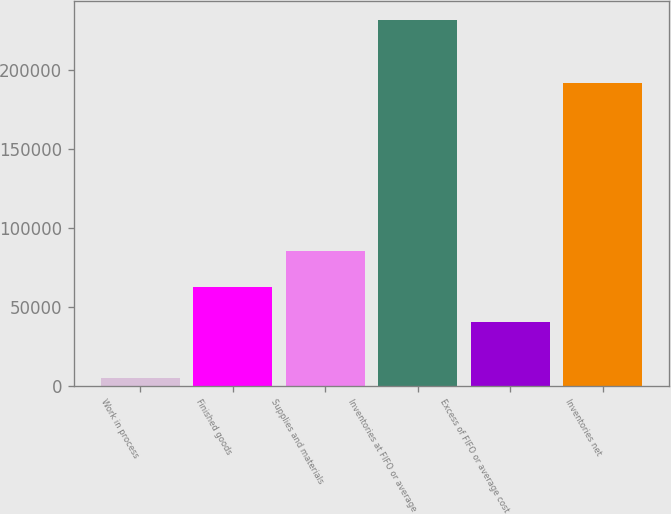Convert chart. <chart><loc_0><loc_0><loc_500><loc_500><bar_chart><fcel>Work in process<fcel>Finished goods<fcel>Supplies and materials<fcel>Inventories at FIFO or average<fcel>Excess of FIFO or average cost<fcel>Inventories net<nl><fcel>5119<fcel>62991<fcel>85691<fcel>232119<fcel>40291<fcel>191828<nl></chart> 